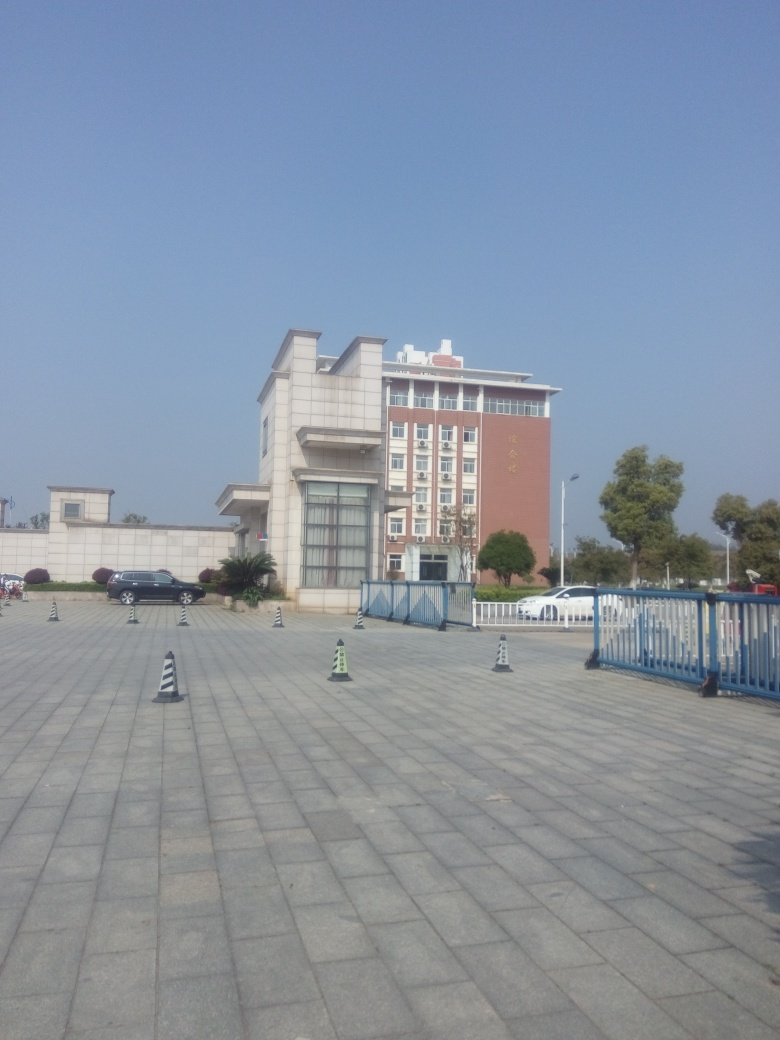What architectural style does this building represent? The building's architectural style takes inspiration from modern design, emphasizing functionality with its clean lines and utilitarian structure, while also integrating traditional elements that suggest a respect for historical context. 